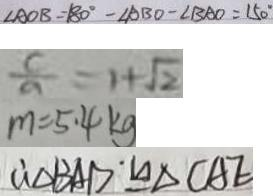<formula> <loc_0><loc_0><loc_500><loc_500>\angle A O B = 1 8 0 ^ { \circ } - \angle A B O - \angle B A O = 1 5 0 ^ { \circ } 
 \frac { c } { a } = 1 + \sqrt { 2 } 
 m = 5 . 4 k g 
 \therefore \Delta B A D \cong \Delta C A E</formula> 